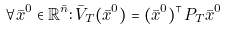Convert formula to latex. <formula><loc_0><loc_0><loc_500><loc_500>\forall \bar { x } ^ { 0 } \in \mathbb { R } ^ { \bar { n } } \colon \bar { V } _ { T } ( \bar { x } ^ { 0 } ) = ( \bar { x } ^ { 0 } ) ^ { \top } P _ { T } \bar { x } ^ { 0 }</formula> 